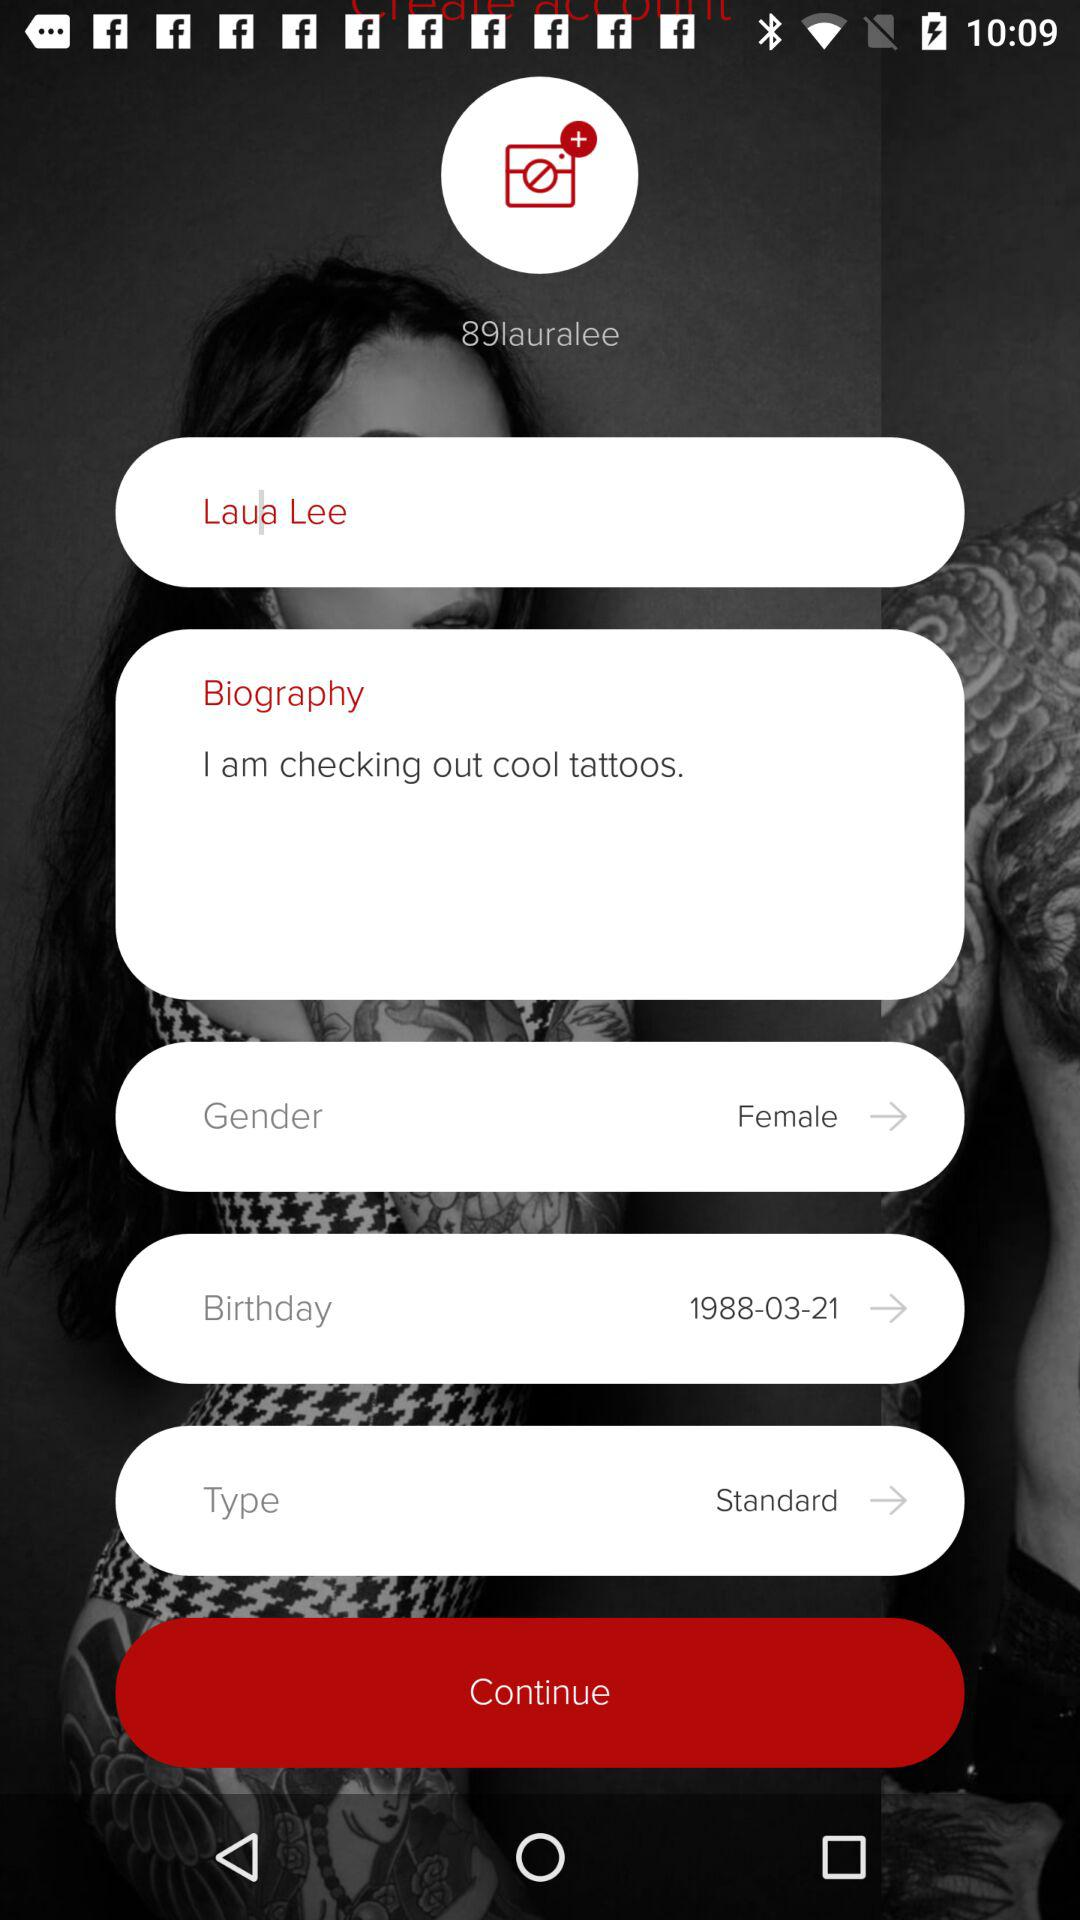What is the name of the user? The name of the user is Laua Lee. 